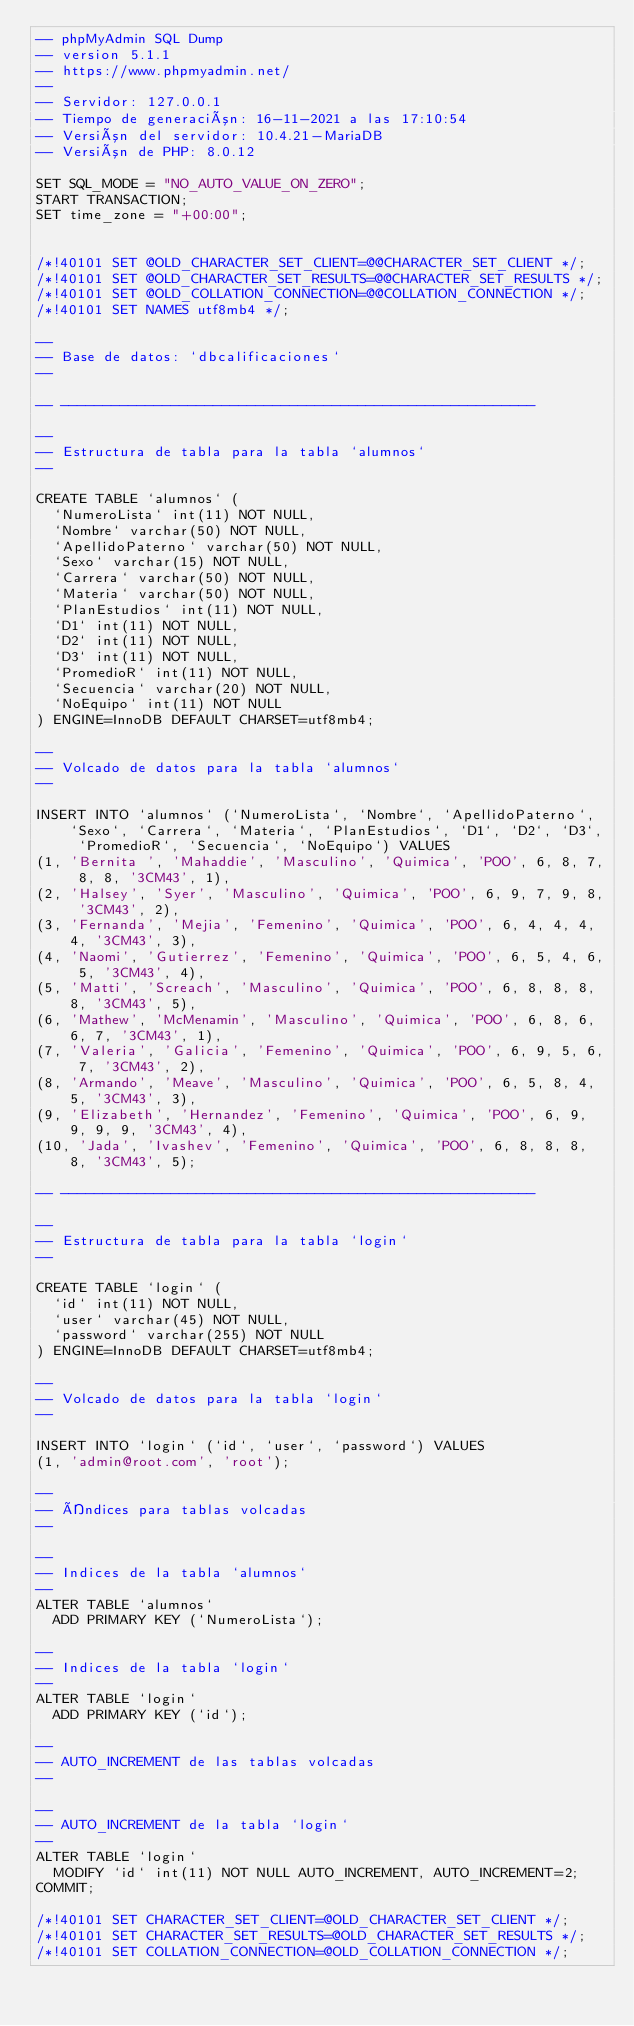Convert code to text. <code><loc_0><loc_0><loc_500><loc_500><_SQL_>-- phpMyAdmin SQL Dump
-- version 5.1.1
-- https://www.phpmyadmin.net/
--
-- Servidor: 127.0.0.1
-- Tiempo de generación: 16-11-2021 a las 17:10:54
-- Versión del servidor: 10.4.21-MariaDB
-- Versión de PHP: 8.0.12

SET SQL_MODE = "NO_AUTO_VALUE_ON_ZERO";
START TRANSACTION;
SET time_zone = "+00:00";


/*!40101 SET @OLD_CHARACTER_SET_CLIENT=@@CHARACTER_SET_CLIENT */;
/*!40101 SET @OLD_CHARACTER_SET_RESULTS=@@CHARACTER_SET_RESULTS */;
/*!40101 SET @OLD_COLLATION_CONNECTION=@@COLLATION_CONNECTION */;
/*!40101 SET NAMES utf8mb4 */;

--
-- Base de datos: `dbcalificaciones`
--

-- --------------------------------------------------------

--
-- Estructura de tabla para la tabla `alumnos`
--

CREATE TABLE `alumnos` (
  `NumeroLista` int(11) NOT NULL,
  `Nombre` varchar(50) NOT NULL,
  `ApellidoPaterno` varchar(50) NOT NULL,
  `Sexo` varchar(15) NOT NULL,
  `Carrera` varchar(50) NOT NULL,
  `Materia` varchar(50) NOT NULL,
  `PlanEstudios` int(11) NOT NULL,
  `D1` int(11) NOT NULL,
  `D2` int(11) NOT NULL,
  `D3` int(11) NOT NULL,
  `PromedioR` int(11) NOT NULL,
  `Secuencia` varchar(20) NOT NULL,
  `NoEquipo` int(11) NOT NULL
) ENGINE=InnoDB DEFAULT CHARSET=utf8mb4;

--
-- Volcado de datos para la tabla `alumnos`
--

INSERT INTO `alumnos` (`NumeroLista`, `Nombre`, `ApellidoPaterno`, `Sexo`, `Carrera`, `Materia`, `PlanEstudios`, `D1`, `D2`, `D3`, `PromedioR`, `Secuencia`, `NoEquipo`) VALUES
(1, 'Bernita ', 'Mahaddie', 'Masculino', 'Quimica', 'POO', 6, 8, 7, 8, 8, '3CM43', 1),
(2, 'Halsey', 'Syer', 'Masculino', 'Quimica', 'POO', 6, 9, 7, 9, 8, '3CM43', 2),
(3, 'Fernanda', 'Mejia', 'Femenino', 'Quimica', 'POO', 6, 4, 4, 4, 4, '3CM43', 3),
(4, 'Naomi', 'Gutierrez', 'Femenino', 'Quimica', 'POO', 6, 5, 4, 6, 5, '3CM43', 4),
(5, 'Matti', 'Screach', 'Masculino', 'Quimica', 'POO', 6, 8, 8, 8, 8, '3CM43', 5),
(6, 'Mathew', 'McMenamin', 'Masculino', 'Quimica', 'POO', 6, 8, 6, 6, 7, '3CM43', 1),
(7, 'Valeria', 'Galicia', 'Femenino', 'Quimica', 'POO', 6, 9, 5, 6, 7, '3CM43', 2),
(8, 'Armando', 'Meave', 'Masculino', 'Quimica', 'POO', 6, 5, 8, 4, 5, '3CM43', 3),
(9, 'Elizabeth', 'Hernandez', 'Femenino', 'Quimica', 'POO', 6, 9, 9, 9, 9, '3CM43', 4),
(10, 'Jada', 'Ivashev', 'Femenino', 'Quimica', 'POO', 6, 8, 8, 8, 8, '3CM43', 5);

-- --------------------------------------------------------

--
-- Estructura de tabla para la tabla `login`
--

CREATE TABLE `login` (
  `id` int(11) NOT NULL,
  `user` varchar(45) NOT NULL,
  `password` varchar(255) NOT NULL
) ENGINE=InnoDB DEFAULT CHARSET=utf8mb4;

--
-- Volcado de datos para la tabla `login`
--

INSERT INTO `login` (`id`, `user`, `password`) VALUES
(1, 'admin@root.com', 'root');

--
-- Índices para tablas volcadas
--

--
-- Indices de la tabla `alumnos`
--
ALTER TABLE `alumnos`
  ADD PRIMARY KEY (`NumeroLista`);

--
-- Indices de la tabla `login`
--
ALTER TABLE `login`
  ADD PRIMARY KEY (`id`);

--
-- AUTO_INCREMENT de las tablas volcadas
--

--
-- AUTO_INCREMENT de la tabla `login`
--
ALTER TABLE `login`
  MODIFY `id` int(11) NOT NULL AUTO_INCREMENT, AUTO_INCREMENT=2;
COMMIT;

/*!40101 SET CHARACTER_SET_CLIENT=@OLD_CHARACTER_SET_CLIENT */;
/*!40101 SET CHARACTER_SET_RESULTS=@OLD_CHARACTER_SET_RESULTS */;
/*!40101 SET COLLATION_CONNECTION=@OLD_COLLATION_CONNECTION */;
</code> 